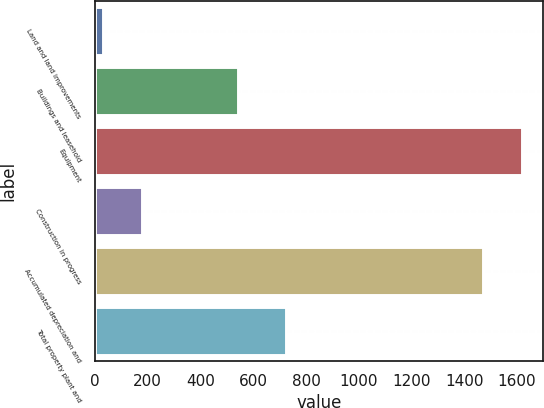Convert chart. <chart><loc_0><loc_0><loc_500><loc_500><bar_chart><fcel>Land and land improvements<fcel>Buildings and leasehold<fcel>Equipment<fcel>Construction in progress<fcel>Accumulated depreciation and<fcel>Total property plant and<nl><fcel>31<fcel>544<fcel>1617.6<fcel>178.6<fcel>1470<fcel>726<nl></chart> 